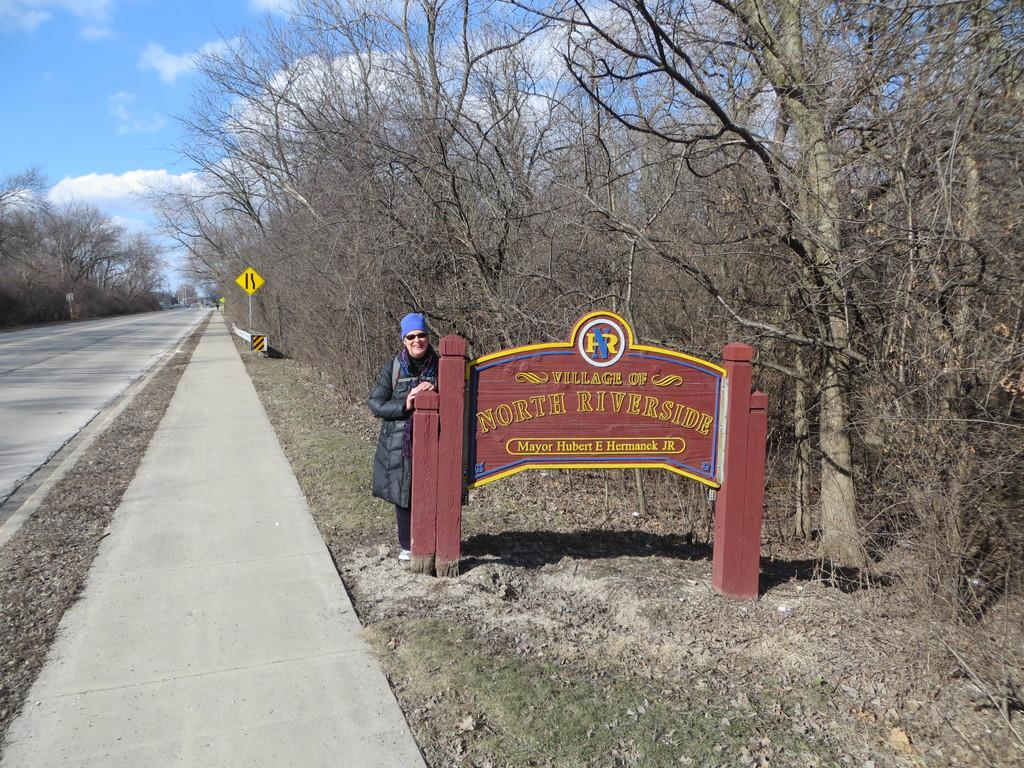<image>
Summarize the visual content of the image. A woman standing next to a sign for the village of North River. 